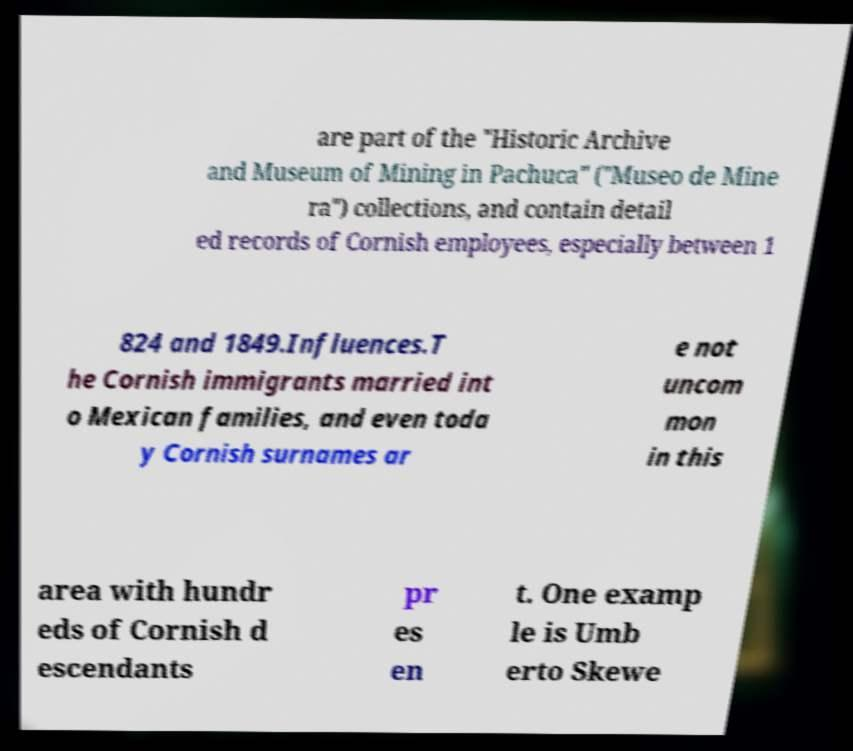I need the written content from this picture converted into text. Can you do that? are part of the "Historic Archive and Museum of Mining in Pachuca" ("Museo de Mine ra") collections, and contain detail ed records of Cornish employees, especially between 1 824 and 1849.Influences.T he Cornish immigrants married int o Mexican families, and even toda y Cornish surnames ar e not uncom mon in this area with hundr eds of Cornish d escendants pr es en t. One examp le is Umb erto Skewe 